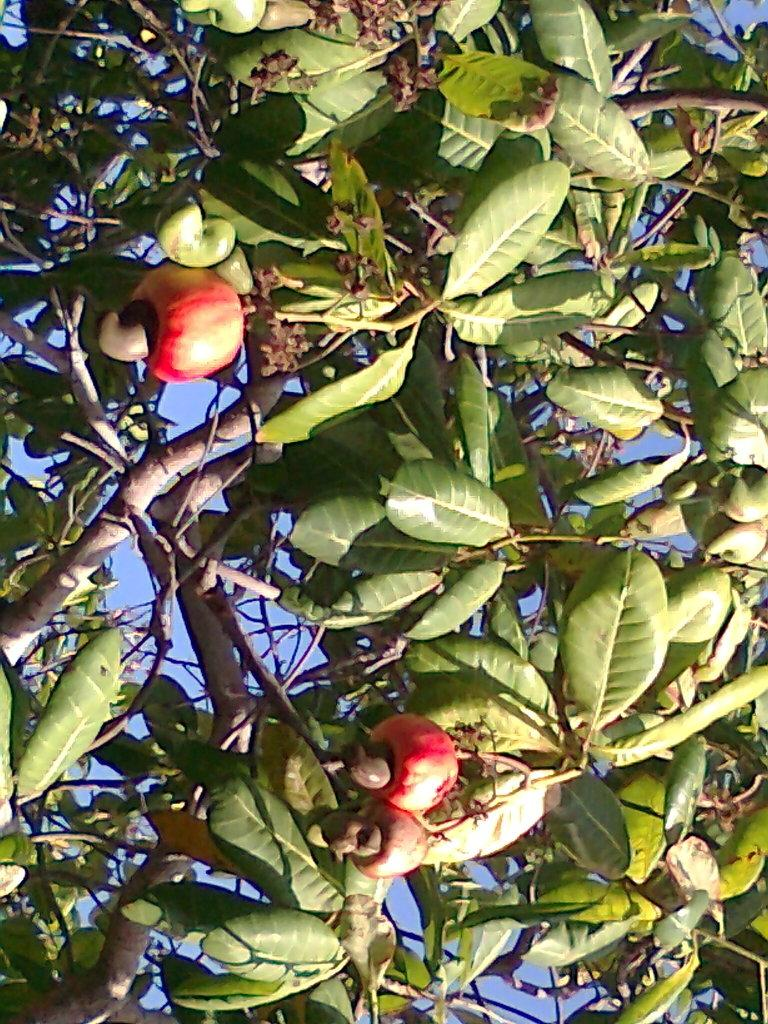What is the main subject of the image? The main subject of the image is a part of a tree. What can be observed about the tree in the image? The tree has many leaves and fruits in red and green colors. What is visible in the background of the image? The sky is visible in the background of the image. What type of drink is being served in the middle of the image? There is no drink present in the image; it features a part of a tree with leaves and fruits. What kind of art is displayed on the tree in the image? There is no art displayed on the tree in the image; it is a natural tree with leaves and fruits. 